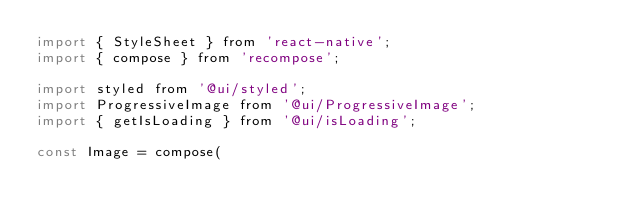<code> <loc_0><loc_0><loc_500><loc_500><_JavaScript_>import { StyleSheet } from 'react-native';
import { compose } from 'recompose';

import styled from '@ui/styled';
import ProgressiveImage from '@ui/ProgressiveImage';
import { getIsLoading } from '@ui/isLoading';

const Image = compose(</code> 